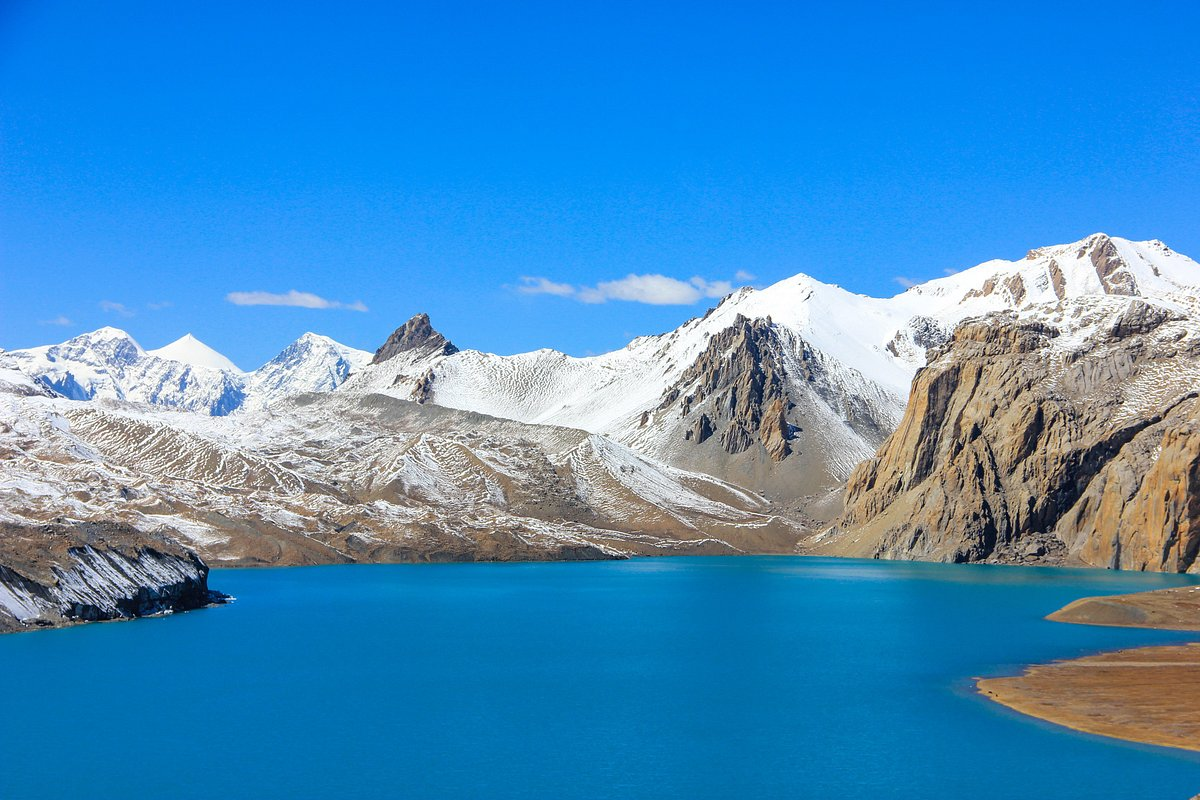What kind of flora and fauna might live in the area surrounding Tilicho Lake? In the high-altitude region surrounding Tilicho Lake, you can find a variety of flora and fauna adapted to the cold and rugged conditions. Flora includes alpine plants, such as various grasses, mosses, and lichens, which thrive despite the harsh environment. Dwarf shrubs and hardy perennial herbs can also be spotted. As for fauna, you'd encounter mountain wildlife like the Himalayan tahr, blue sheep, and snow leopards, along with smaller mammals such as marmots and pikas. Bird species around this area might include the Himalayan griffon and various high-altitude adapted birds. 